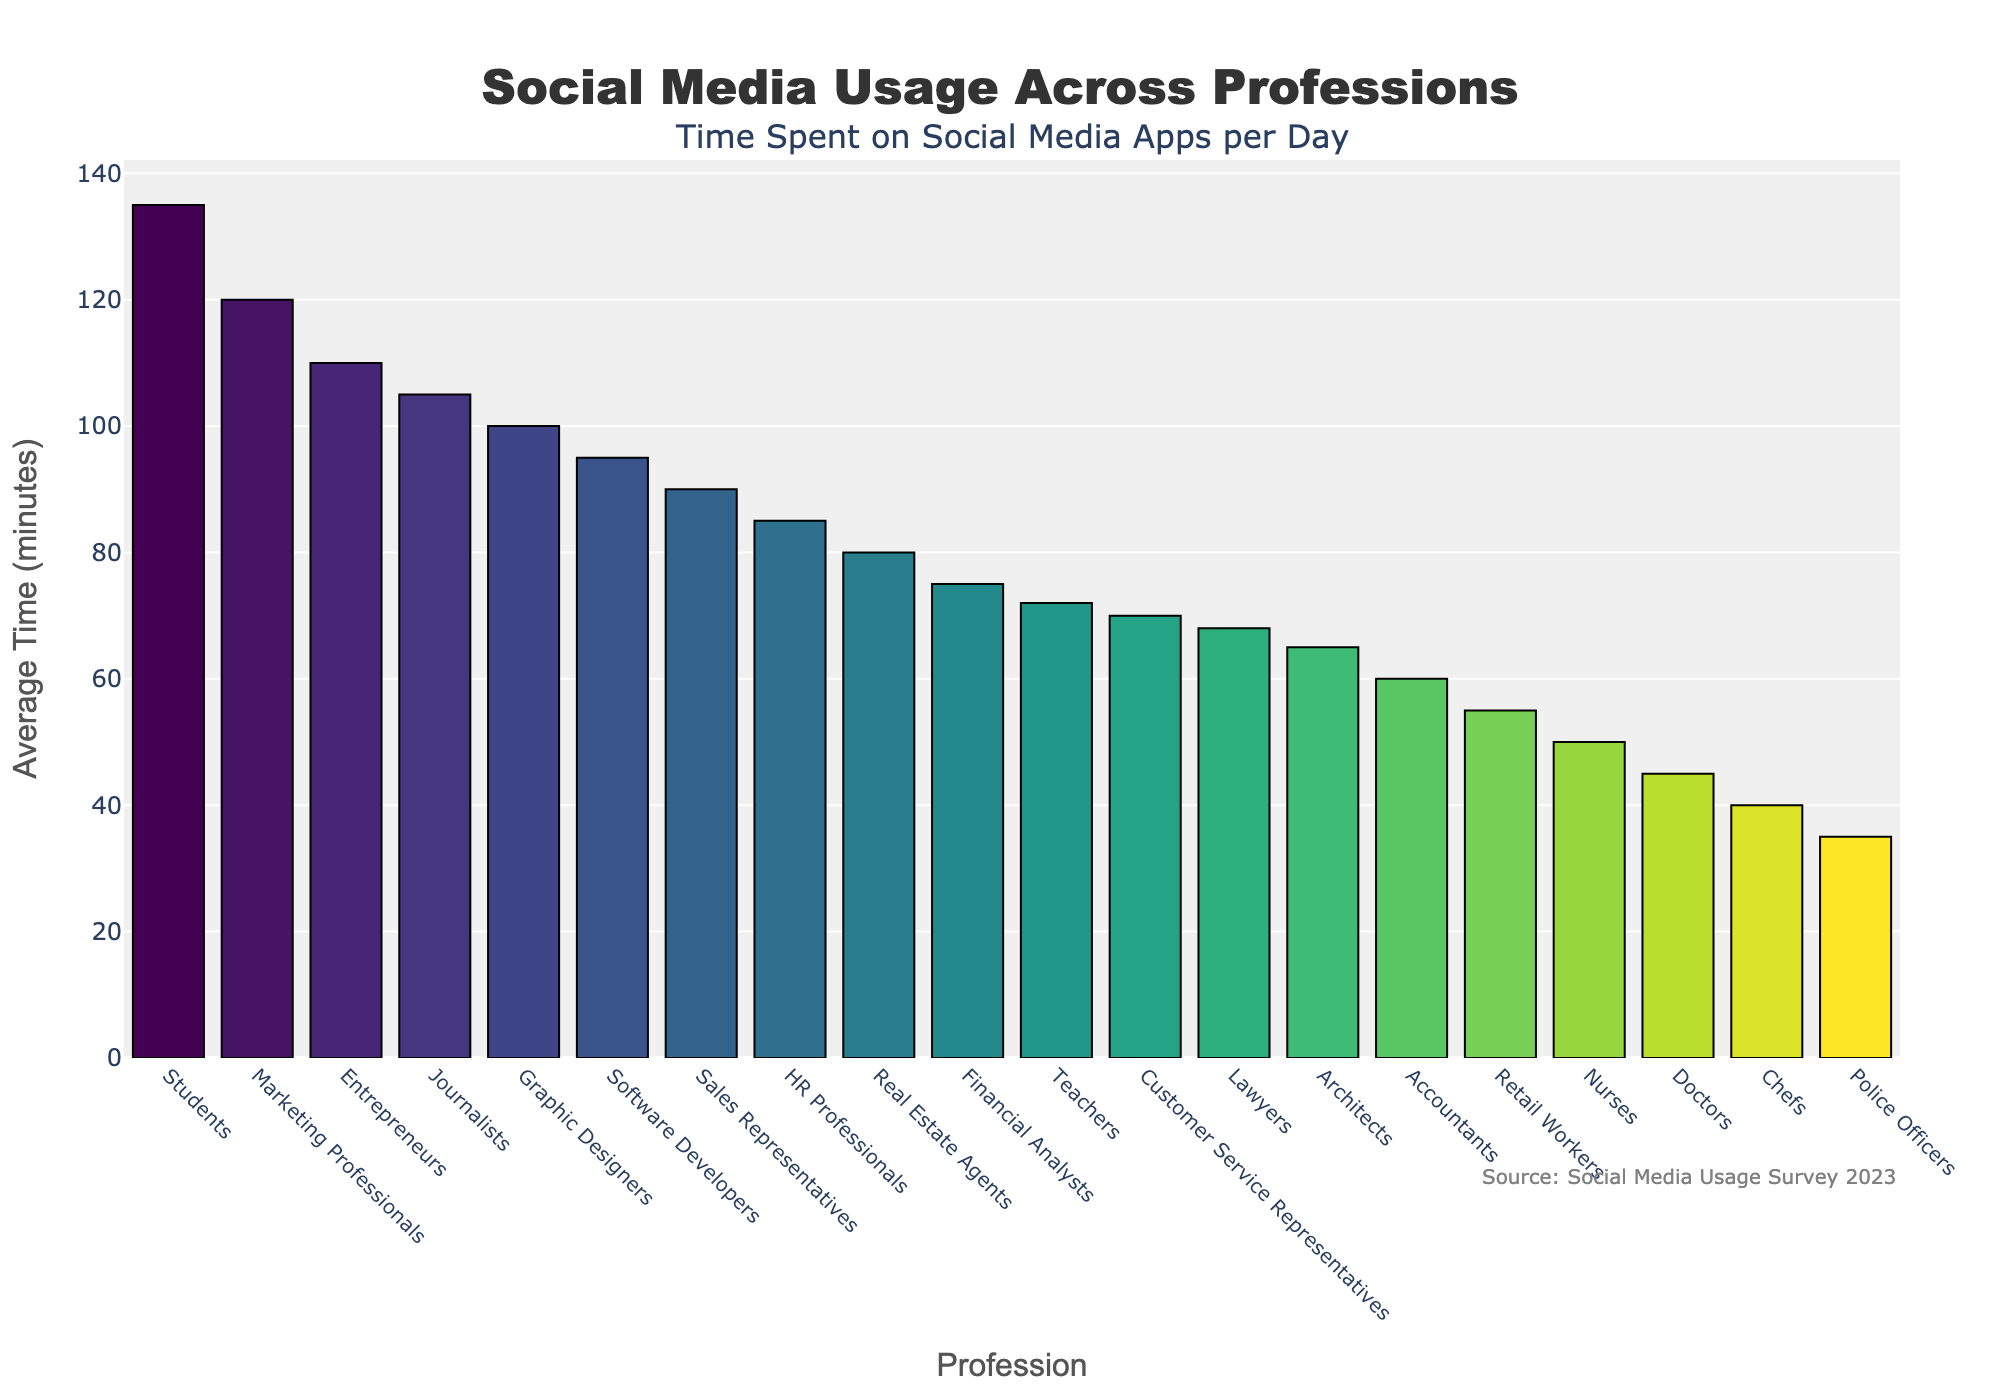What's the average time spent on social media by Software Developers and Teachers combined? To find the average, sum the time spent by Software Developers (95 minutes) and Teachers (72 minutes), which gives 167 minutes combined. The number of professions involved is 2, so the average is 167/2 = 83.5 minutes.
Answer: 83.5 minutes Which profession spends the most time on social media? The profession with the highest bar and corresponding value is Students, who spend 135 minutes.
Answer: Students How much more time do Marketing Professionals spend on social media daily compared to Doctors? The average time spent by Marketing Professionals is 120 minutes and by Doctors is 45 minutes. The difference is 120 - 45 = 75 minutes.
Answer: 75 minutes Rank the top three professions that spend the most time on social media. The top three bars by height represent Students (135 minutes), Marketing Professionals (120 minutes), and Journalists (105 minutes).
Answer: Students, Marketing Professionals, Journalists If you were to calculate the median time spent across all professions, what challenges might arise? To find the median, the data needs to be ordered. Since there are 20 professions, the median will be the average of the 10th and 11th values. However, exact values for each profession would be required, making it somewhat challenging to calculate without a table.
Answer: Median calculation requires precise ordering and middle values Which professions spend less than 50 minutes on social media per day? The bars that fall below 50 minutes are Chefs (40 minutes) and Police Officers (35 minutes).
Answer: Chefs, Police Officers What is the range of time spent on social media across all listed professions? The range is the difference between the highest and lowest values. The highest is 135 minutes (Students) and the lowest is 35 minutes (Police Officers). The range is 135 - 35 = 100 minutes.
Answer: 100 minutes How does the social media usage of HR Professionals compare to that of Real Estate Agents? HR Professionals spend 85 minutes, while Real Estate Agents spend 80 minutes. HR Professionals spend 5 minutes more.
Answer: 5 minutes more Which profession spends exactly 60 minutes on social media? The bar corresponding to exactly 60 minutes belongs to Accountants.
Answer: Accountants Is the average time spent by Teachers higher or lower than the overall average time of all professions combined? First, find the total time and average. Sum all times (72 + 45 + 95 + 68 + 120 + 105 + 135 + 90 + 60 + 85 + 110 + 55 + 100 + 40 + 80 + 70 + 50 + 65 + 75 + 35 = 1515) and divide by 20. The overall average is 1515/20 = 75.75 minutes. Teachers spend 72 minutes, which is lower than 75.75 minutes.
Answer: Lower 